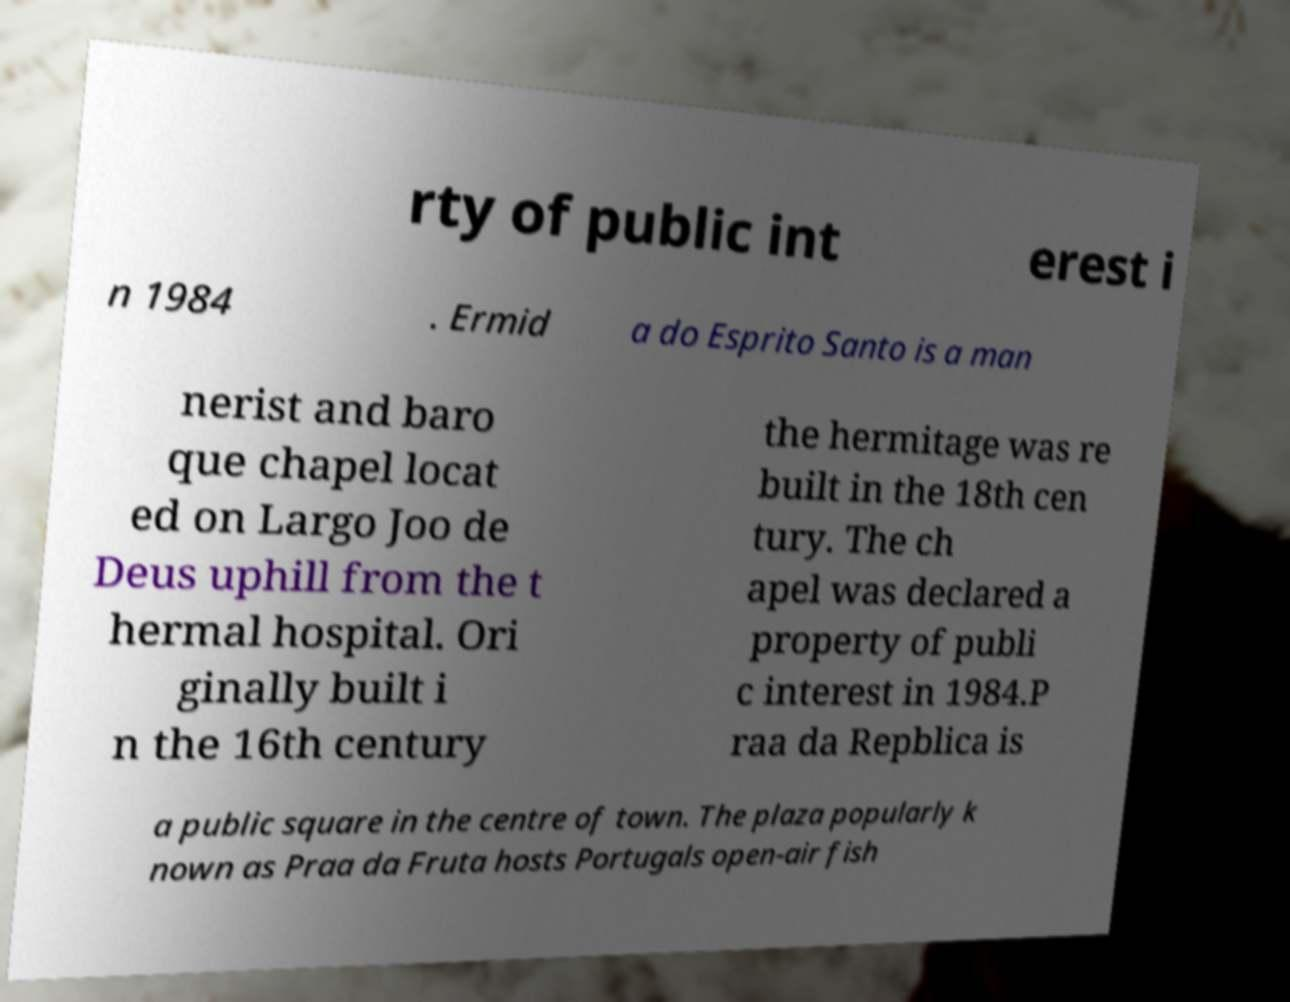I need the written content from this picture converted into text. Can you do that? rty of public int erest i n 1984 . Ermid a do Esprito Santo is a man nerist and baro que chapel locat ed on Largo Joo de Deus uphill from the t hermal hospital. Ori ginally built i n the 16th century the hermitage was re built in the 18th cen tury. The ch apel was declared a property of publi c interest in 1984.P raa da Repblica is a public square in the centre of town. The plaza popularly k nown as Praa da Fruta hosts Portugals open-air fish 